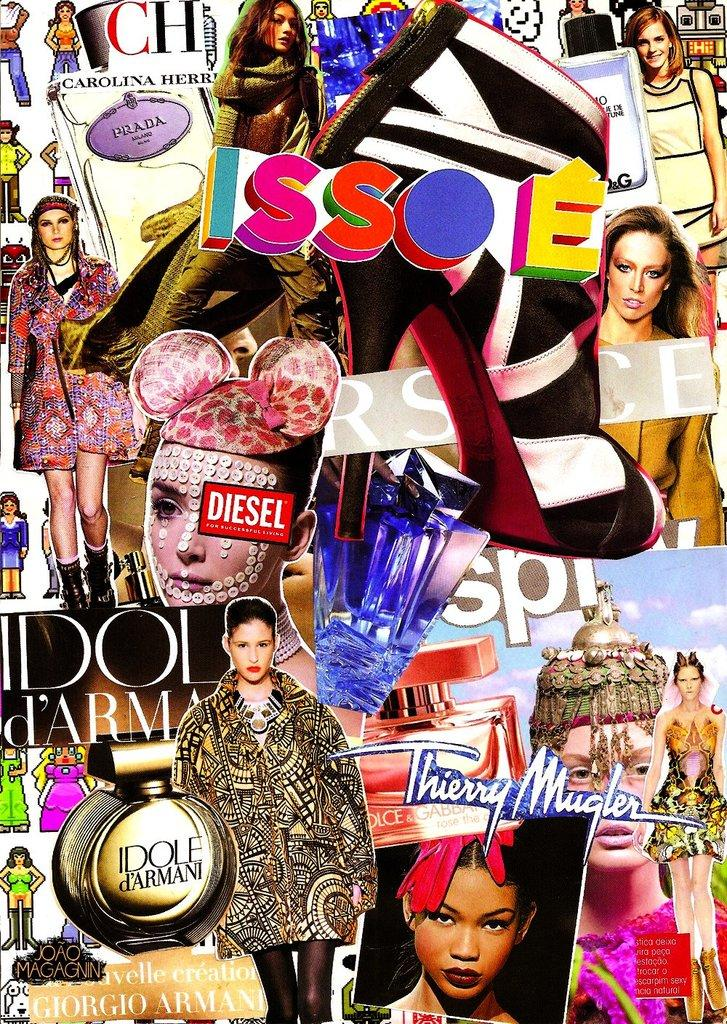<image>
Share a concise interpretation of the image provided. A collage of various fashion models featuring Idole d'Armani perfume. 